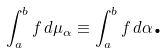Convert formula to latex. <formula><loc_0><loc_0><loc_500><loc_500>\int _ { a } ^ { b } f \, d \mu _ { \alpha } \equiv \int _ { a } ^ { b } f \, d \alpha \text {.}</formula> 